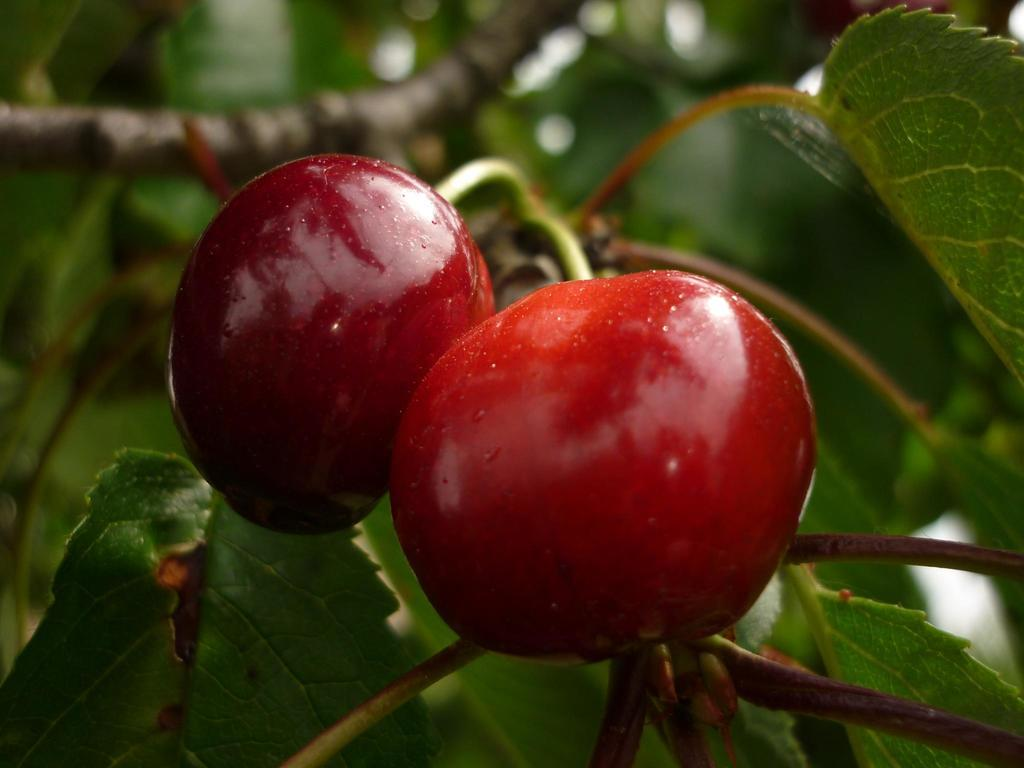What type of fruit can be seen in the picture? There are berries in the picture. What color are the leaves in the picture? The leaves in the picture are green. What part of the tree is depicted in the picture? The elements appear to be part of a tree branch. Where is the branch located in the picture? The branch is located on the top left side of the picture. What time of day does the force of the beginner start in the image? There is no reference to time, force, or a beginner in the image; it features berries, green leaves, and a tree branch. 